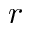Convert formula to latex. <formula><loc_0><loc_0><loc_500><loc_500>r</formula> 